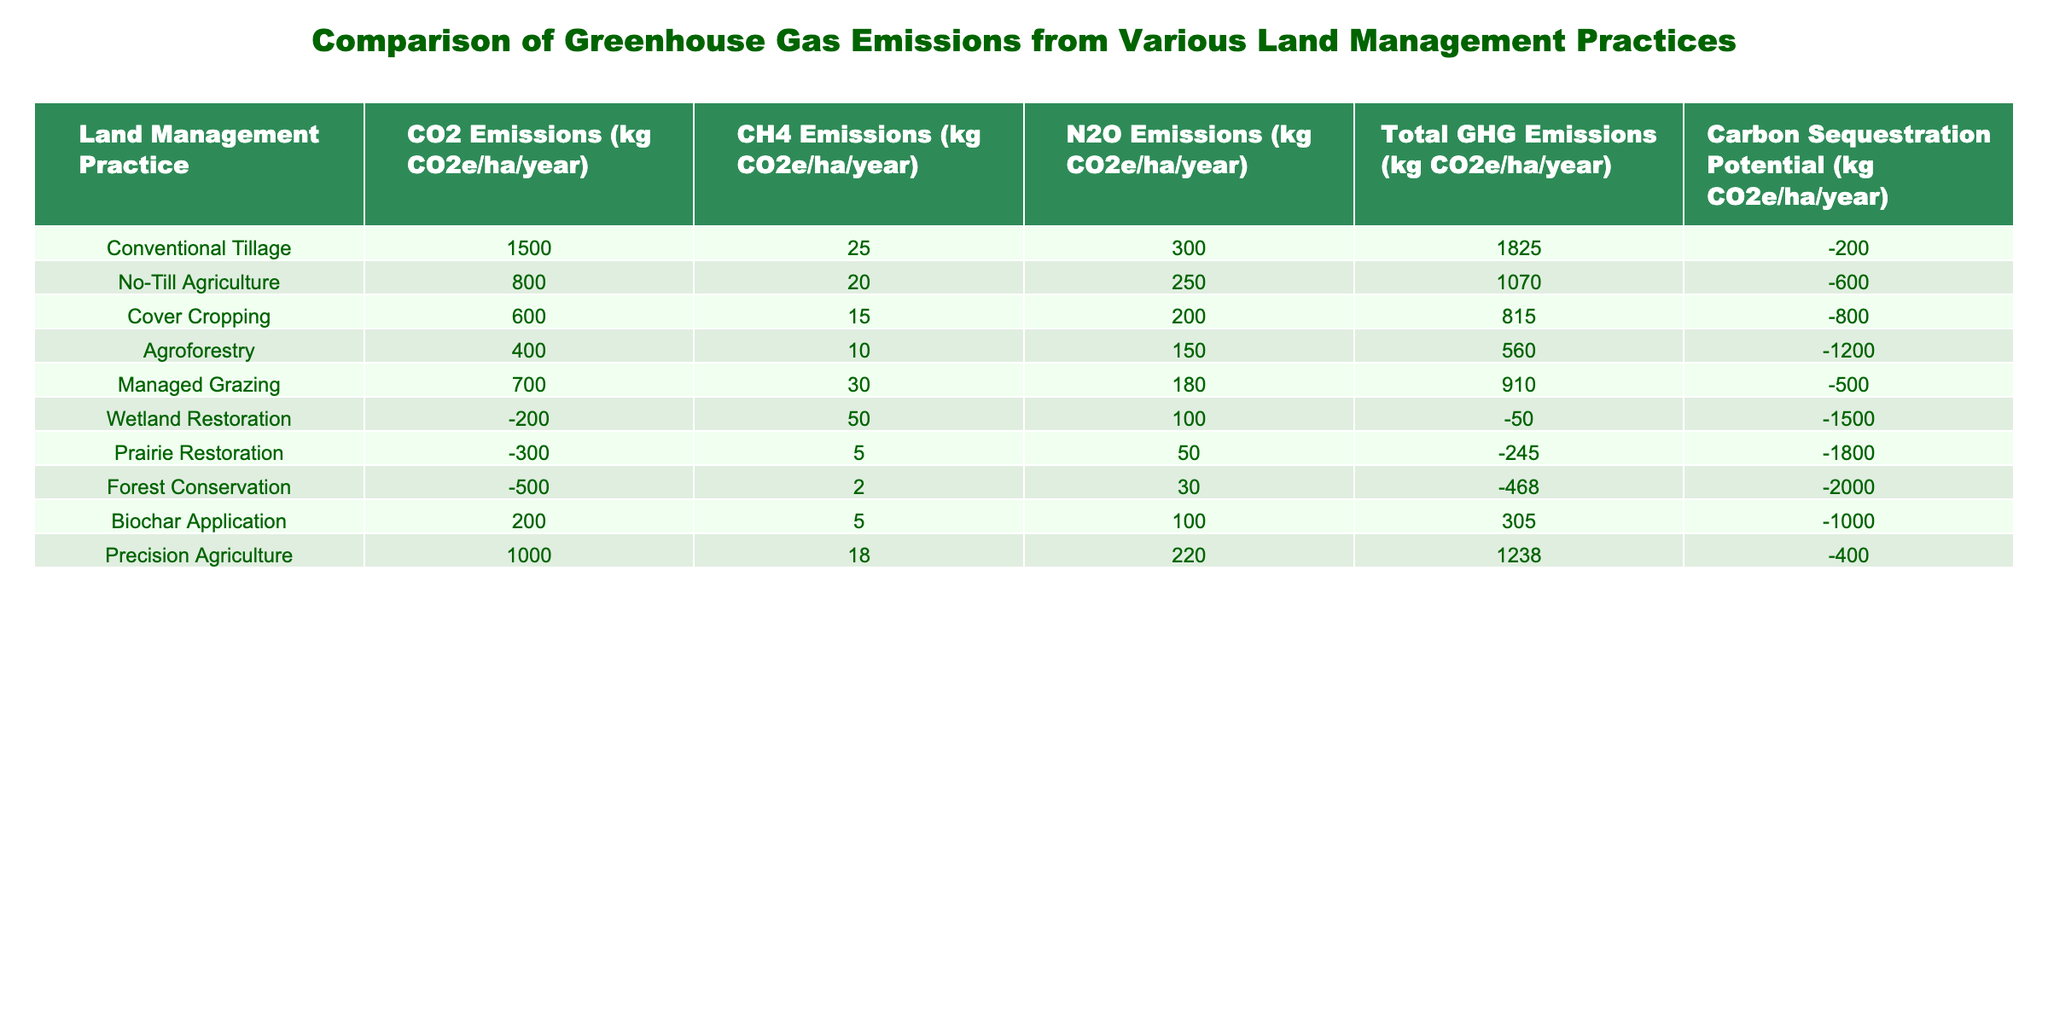What is the total GHG emissions for Conventional Tillage? The table shows that Conventional Tillage has total GHG emissions of 1825 kg CO2e/ha/year. I can confirm this by finding the corresponding value in the "Total GHG Emissions" column for the row labeled "Conventional Tillage."
Answer: 1825 kg CO2e/ha/year Which land management practice has the highest N2O emissions? By examining the N2O emissions column, I see that Conventional Tillage has the highest value at 300 kg CO2e/ha/year. Thus, it can be concluded that this practice produces the most N2O emissions.
Answer: Conventional Tillage What is the difference in CO2 emissions between No-Till Agriculture and Agroforestry? To find the difference, I subtract the CO2 emissions of Agroforestry (400 kg CO2e/ha/year) from that of No-Till Agriculture (800 kg CO2e/ha/year). The calculation yields 800 - 400 = 400 kg CO2e/ha/year.
Answer: 400 kg CO2e/ha/year Is the carbon sequestration potential of Wetland Restoration greater than that of Biochar Application? I check the carbon sequestration potential values: Wetland Restoration is -1500 kg CO2e/ha/year, and Biochar Application is -1000 kg CO2e/ha/year. Since -1500 is less than -1000, I conclude that Wetland Restoration's potential is indeed less.
Answer: No What is the average total GHG emissions for all the land management practices listed? First, I need to sum the total GHG emissions for all practices: 1825 + 1070 + 815 + 560 + 910 - 50 - 245 - 468 + 305 + 1238 = 5070 kg CO2e/ha/year. Then, since there are 10 different practices, I divide by 10 to find the average: 5070 / 10 = 507 kg CO2e/ha/year.
Answer: 507 kg CO2e/ha/year Which land management practices have negative carbon sequestration potential? I need to scan the carbon sequestration potential column for any negative values. The practices that show negative values are: No-Till Agriculture, Cover Cropping, Agroforestry, Wetland Restoration, Prairie Restoration, Forest Conservation, and Biochar Application. Overall, these six practices demonstrate negative potential.
Answer: 6 practices 